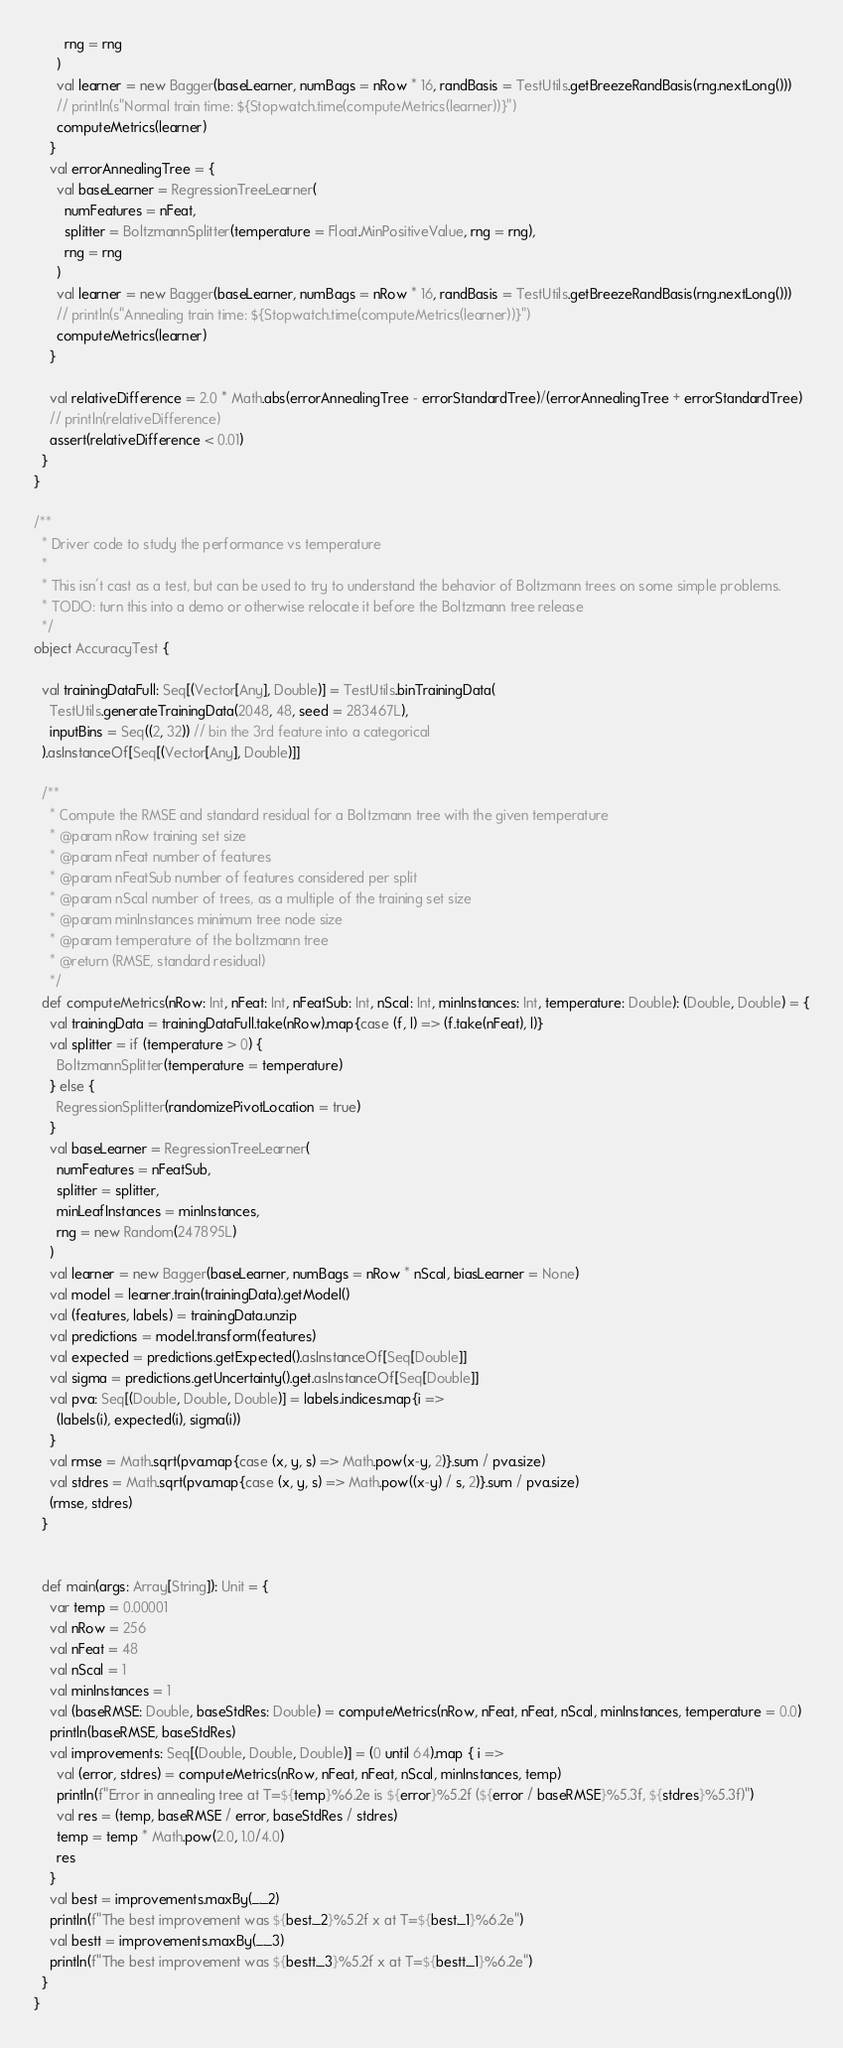Convert code to text. <code><loc_0><loc_0><loc_500><loc_500><_Scala_>        rng = rng
      )
      val learner = new Bagger(baseLearner, numBags = nRow * 16, randBasis = TestUtils.getBreezeRandBasis(rng.nextLong()))
      // println(s"Normal train time: ${Stopwatch.time(computeMetrics(learner))}")
      computeMetrics(learner)
    }
    val errorAnnealingTree = {
      val baseLearner = RegressionTreeLearner(
        numFeatures = nFeat,
        splitter = BoltzmannSplitter(temperature = Float.MinPositiveValue, rng = rng),
        rng = rng
      )
      val learner = new Bagger(baseLearner, numBags = nRow * 16, randBasis = TestUtils.getBreezeRandBasis(rng.nextLong()))
      // println(s"Annealing train time: ${Stopwatch.time(computeMetrics(learner))}")
      computeMetrics(learner)
    }

    val relativeDifference = 2.0 * Math.abs(errorAnnealingTree - errorStandardTree)/(errorAnnealingTree + errorStandardTree)
    // println(relativeDifference)
    assert(relativeDifference < 0.01)
  }
}

/**
  * Driver code to study the performance vs temperature
  *
  * This isn't cast as a test, but can be used to try to understand the behavior of Boltzmann trees on some simple problems.
  * TODO: turn this into a demo or otherwise relocate it before the Boltzmann tree release
  */
object AccuracyTest {

  val trainingDataFull: Seq[(Vector[Any], Double)] = TestUtils.binTrainingData(
    TestUtils.generateTrainingData(2048, 48, seed = 283467L),
    inputBins = Seq((2, 32)) // bin the 3rd feature into a categorical
  ).asInstanceOf[Seq[(Vector[Any], Double)]]

  /**
    * Compute the RMSE and standard residual for a Boltzmann tree with the given temperature
    * @param nRow training set size
    * @param nFeat number of features
    * @param nFeatSub number of features considered per split
    * @param nScal number of trees, as a multiple of the training set size
    * @param minInstances minimum tree node size
    * @param temperature of the boltzmann tree
    * @return (RMSE, standard residual)
    */
  def computeMetrics(nRow: Int, nFeat: Int, nFeatSub: Int, nScal: Int, minInstances: Int, temperature: Double): (Double, Double) = {
    val trainingData = trainingDataFull.take(nRow).map{case (f, l) => (f.take(nFeat), l)}
    val splitter = if (temperature > 0) {
      BoltzmannSplitter(temperature = temperature)
    } else {
      RegressionSplitter(randomizePivotLocation = true)
    }
    val baseLearner = RegressionTreeLearner(
      numFeatures = nFeatSub,
      splitter = splitter,
      minLeafInstances = minInstances,
      rng = new Random(247895L)
    )
    val learner = new Bagger(baseLearner, numBags = nRow * nScal, biasLearner = None)
    val model = learner.train(trainingData).getModel()
    val (features, labels) = trainingData.unzip
    val predictions = model.transform(features)
    val expected = predictions.getExpected().asInstanceOf[Seq[Double]]
    val sigma = predictions.getUncertainty().get.asInstanceOf[Seq[Double]]
    val pva: Seq[(Double, Double, Double)] = labels.indices.map{i =>
      (labels(i), expected(i), sigma(i))
    }
    val rmse = Math.sqrt(pva.map{case (x, y, s) => Math.pow(x-y, 2)}.sum / pva.size)
    val stdres = Math.sqrt(pva.map{case (x, y, s) => Math.pow((x-y) / s, 2)}.sum / pva.size)
    (rmse, stdres)
  }


  def main(args: Array[String]): Unit = {
    var temp = 0.00001
    val nRow = 256
    val nFeat = 48
    val nScal = 1
    val minInstances = 1
    val (baseRMSE: Double, baseStdRes: Double) = computeMetrics(nRow, nFeat, nFeat, nScal, minInstances, temperature = 0.0)
    println(baseRMSE, baseStdRes)
    val improvements: Seq[(Double, Double, Double)] = (0 until 64).map { i =>
      val (error, stdres) = computeMetrics(nRow, nFeat, nFeat, nScal, minInstances, temp)
      println(f"Error in annealing tree at T=${temp}%6.2e is ${error}%5.2f (${error / baseRMSE}%5.3f, ${stdres}%5.3f)")
      val res = (temp, baseRMSE / error, baseStdRes / stdres)
      temp = temp * Math.pow(2.0, 1.0/4.0)
      res
    }
    val best = improvements.maxBy(_._2)
    println(f"The best improvement was ${best._2}%5.2f x at T=${best._1}%6.2e")
    val bestt = improvements.maxBy(_._3)
    println(f"The best improvement was ${bestt._3}%5.2f x at T=${bestt._1}%6.2e")
  }
}
</code> 